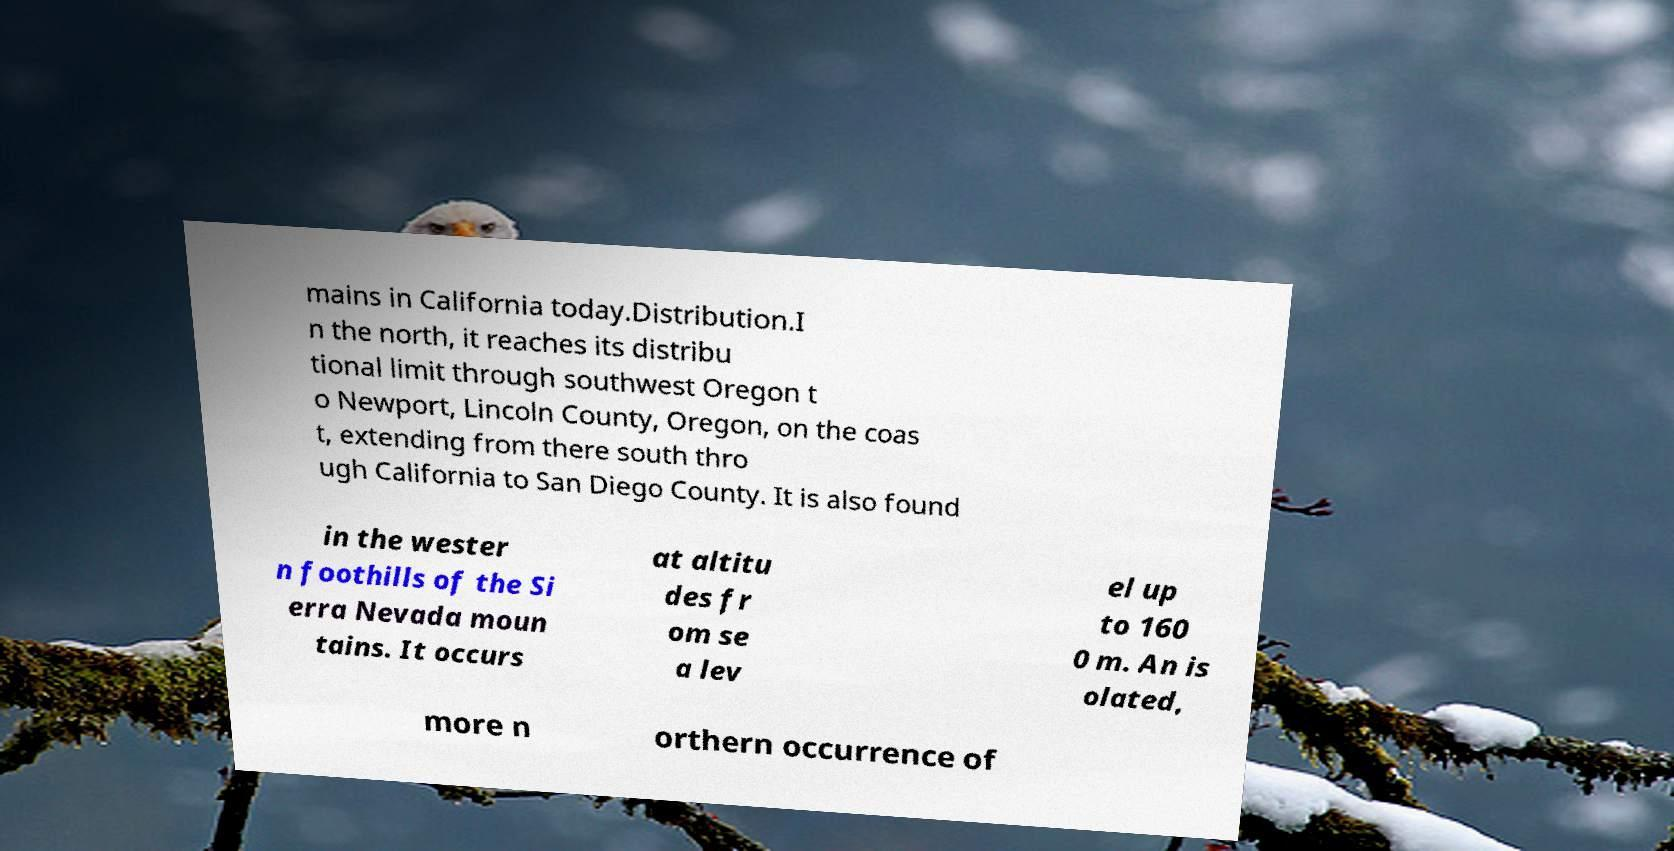I need the written content from this picture converted into text. Can you do that? mains in California today.Distribution.I n the north, it reaches its distribu tional limit through southwest Oregon t o Newport, Lincoln County, Oregon, on the coas t, extending from there south thro ugh California to San Diego County. It is also found in the wester n foothills of the Si erra Nevada moun tains. It occurs at altitu des fr om se a lev el up to 160 0 m. An is olated, more n orthern occurrence of 